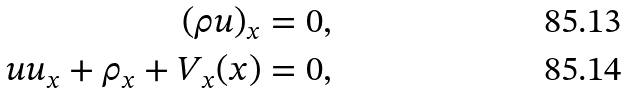Convert formula to latex. <formula><loc_0><loc_0><loc_500><loc_500>( \rho u ) _ { x } = 0 , \\ u u _ { x } + \rho _ { x } + V _ { x } ( x ) = 0 ,</formula> 